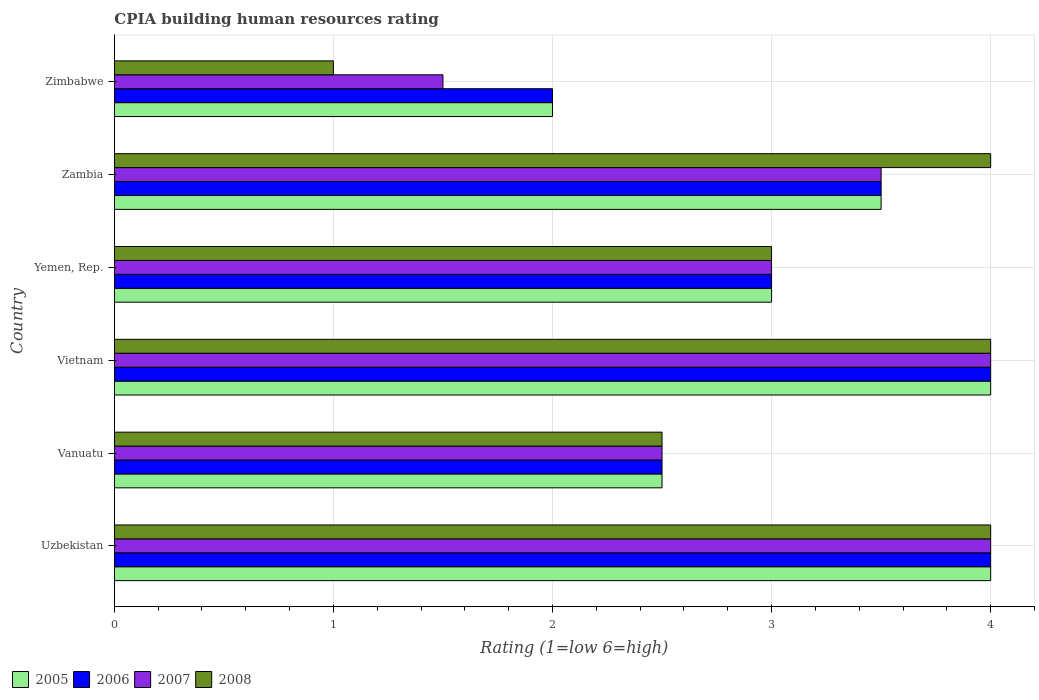How many groups of bars are there?
Offer a very short reply. 6. Are the number of bars per tick equal to the number of legend labels?
Offer a very short reply. Yes. Are the number of bars on each tick of the Y-axis equal?
Ensure brevity in your answer.  Yes. How many bars are there on the 1st tick from the bottom?
Make the answer very short. 4. What is the label of the 4th group of bars from the top?
Provide a short and direct response. Vietnam. What is the CPIA rating in 2006 in Uzbekistan?
Keep it short and to the point. 4. Across all countries, what is the maximum CPIA rating in 2005?
Provide a succinct answer. 4. In which country was the CPIA rating in 2008 maximum?
Ensure brevity in your answer.  Uzbekistan. In which country was the CPIA rating in 2008 minimum?
Provide a short and direct response. Zimbabwe. What is the total CPIA rating in 2005 in the graph?
Keep it short and to the point. 19. What is the difference between the CPIA rating in 2007 in Zambia and the CPIA rating in 2005 in Vanuatu?
Offer a terse response. 1. What is the average CPIA rating in 2006 per country?
Offer a terse response. 3.17. In how many countries, is the CPIA rating in 2007 greater than 1.8 ?
Offer a very short reply. 5. What is the ratio of the CPIA rating in 2008 in Vanuatu to that in Zimbabwe?
Keep it short and to the point. 2.5. What is the difference between the highest and the lowest CPIA rating in 2008?
Offer a very short reply. 3. What does the 1st bar from the top in Vietnam represents?
Provide a short and direct response. 2008. How many countries are there in the graph?
Offer a terse response. 6. Does the graph contain grids?
Provide a succinct answer. Yes. Where does the legend appear in the graph?
Give a very brief answer. Bottom left. What is the title of the graph?
Your answer should be compact. CPIA building human resources rating. Does "1968" appear as one of the legend labels in the graph?
Your answer should be compact. No. What is the Rating (1=low 6=high) of 2005 in Uzbekistan?
Provide a succinct answer. 4. What is the Rating (1=low 6=high) of 2007 in Uzbekistan?
Provide a short and direct response. 4. What is the Rating (1=low 6=high) of 2008 in Vanuatu?
Offer a very short reply. 2.5. What is the Rating (1=low 6=high) in 2006 in Vietnam?
Provide a succinct answer. 4. What is the Rating (1=low 6=high) in 2007 in Vietnam?
Provide a succinct answer. 4. What is the Rating (1=low 6=high) of 2005 in Yemen, Rep.?
Ensure brevity in your answer.  3. What is the Rating (1=low 6=high) in 2006 in Zambia?
Keep it short and to the point. 3.5. What is the Rating (1=low 6=high) in 2008 in Zambia?
Give a very brief answer. 4. Across all countries, what is the maximum Rating (1=low 6=high) in 2005?
Offer a very short reply. 4. Across all countries, what is the minimum Rating (1=low 6=high) in 2006?
Your response must be concise. 2. Across all countries, what is the minimum Rating (1=low 6=high) in 2008?
Provide a succinct answer. 1. What is the total Rating (1=low 6=high) of 2005 in the graph?
Your response must be concise. 19. What is the total Rating (1=low 6=high) of 2008 in the graph?
Offer a very short reply. 18.5. What is the difference between the Rating (1=low 6=high) of 2008 in Uzbekistan and that in Vanuatu?
Provide a succinct answer. 1.5. What is the difference between the Rating (1=low 6=high) in 2005 in Uzbekistan and that in Vietnam?
Offer a very short reply. 0. What is the difference between the Rating (1=low 6=high) of 2006 in Uzbekistan and that in Vietnam?
Provide a succinct answer. 0. What is the difference between the Rating (1=low 6=high) of 2008 in Uzbekistan and that in Vietnam?
Provide a short and direct response. 0. What is the difference between the Rating (1=low 6=high) of 2005 in Uzbekistan and that in Yemen, Rep.?
Offer a terse response. 1. What is the difference between the Rating (1=low 6=high) in 2008 in Uzbekistan and that in Yemen, Rep.?
Give a very brief answer. 1. What is the difference between the Rating (1=low 6=high) of 2005 in Uzbekistan and that in Zambia?
Ensure brevity in your answer.  0.5. What is the difference between the Rating (1=low 6=high) in 2006 in Uzbekistan and that in Zambia?
Ensure brevity in your answer.  0.5. What is the difference between the Rating (1=low 6=high) in 2008 in Uzbekistan and that in Zambia?
Offer a terse response. 0. What is the difference between the Rating (1=low 6=high) of 2005 in Uzbekistan and that in Zimbabwe?
Ensure brevity in your answer.  2. What is the difference between the Rating (1=low 6=high) of 2007 in Uzbekistan and that in Zimbabwe?
Make the answer very short. 2.5. What is the difference between the Rating (1=low 6=high) of 2005 in Vanuatu and that in Vietnam?
Make the answer very short. -1.5. What is the difference between the Rating (1=low 6=high) in 2006 in Vanuatu and that in Vietnam?
Make the answer very short. -1.5. What is the difference between the Rating (1=low 6=high) of 2007 in Vanuatu and that in Yemen, Rep.?
Give a very brief answer. -0.5. What is the difference between the Rating (1=low 6=high) in 2008 in Vanuatu and that in Yemen, Rep.?
Provide a short and direct response. -0.5. What is the difference between the Rating (1=low 6=high) in 2006 in Vanuatu and that in Zambia?
Offer a very short reply. -1. What is the difference between the Rating (1=low 6=high) in 2007 in Vanuatu and that in Zambia?
Your response must be concise. -1. What is the difference between the Rating (1=low 6=high) in 2008 in Vanuatu and that in Zambia?
Offer a terse response. -1.5. What is the difference between the Rating (1=low 6=high) in 2005 in Vanuatu and that in Zimbabwe?
Your answer should be compact. 0.5. What is the difference between the Rating (1=low 6=high) of 2007 in Vanuatu and that in Zimbabwe?
Offer a very short reply. 1. What is the difference between the Rating (1=low 6=high) in 2008 in Vanuatu and that in Zimbabwe?
Offer a terse response. 1.5. What is the difference between the Rating (1=low 6=high) in 2006 in Vietnam and that in Yemen, Rep.?
Provide a succinct answer. 1. What is the difference between the Rating (1=low 6=high) of 2007 in Vietnam and that in Yemen, Rep.?
Offer a terse response. 1. What is the difference between the Rating (1=low 6=high) in 2005 in Vietnam and that in Zambia?
Offer a very short reply. 0.5. What is the difference between the Rating (1=low 6=high) in 2006 in Vietnam and that in Zambia?
Your answer should be very brief. 0.5. What is the difference between the Rating (1=low 6=high) in 2007 in Vietnam and that in Zambia?
Offer a terse response. 0.5. What is the difference between the Rating (1=low 6=high) of 2008 in Vietnam and that in Zambia?
Offer a terse response. 0. What is the difference between the Rating (1=low 6=high) of 2005 in Vietnam and that in Zimbabwe?
Provide a succinct answer. 2. What is the difference between the Rating (1=low 6=high) in 2006 in Vietnam and that in Zimbabwe?
Provide a short and direct response. 2. What is the difference between the Rating (1=low 6=high) in 2007 in Vietnam and that in Zimbabwe?
Keep it short and to the point. 2.5. What is the difference between the Rating (1=low 6=high) of 2008 in Vietnam and that in Zimbabwe?
Offer a very short reply. 3. What is the difference between the Rating (1=low 6=high) of 2005 in Yemen, Rep. and that in Zambia?
Your answer should be compact. -0.5. What is the difference between the Rating (1=low 6=high) in 2008 in Yemen, Rep. and that in Zambia?
Ensure brevity in your answer.  -1. What is the difference between the Rating (1=low 6=high) in 2005 in Yemen, Rep. and that in Zimbabwe?
Provide a succinct answer. 1. What is the difference between the Rating (1=low 6=high) in 2007 in Yemen, Rep. and that in Zimbabwe?
Keep it short and to the point. 1.5. What is the difference between the Rating (1=low 6=high) in 2005 in Zambia and that in Zimbabwe?
Offer a very short reply. 1.5. What is the difference between the Rating (1=low 6=high) in 2005 in Uzbekistan and the Rating (1=low 6=high) in 2006 in Vanuatu?
Your answer should be compact. 1.5. What is the difference between the Rating (1=low 6=high) in 2006 in Uzbekistan and the Rating (1=low 6=high) in 2007 in Vanuatu?
Your answer should be compact. 1.5. What is the difference between the Rating (1=low 6=high) of 2005 in Uzbekistan and the Rating (1=low 6=high) of 2006 in Vietnam?
Give a very brief answer. 0. What is the difference between the Rating (1=low 6=high) of 2007 in Uzbekistan and the Rating (1=low 6=high) of 2008 in Vietnam?
Your answer should be compact. 0. What is the difference between the Rating (1=low 6=high) of 2005 in Uzbekistan and the Rating (1=low 6=high) of 2008 in Yemen, Rep.?
Keep it short and to the point. 1. What is the difference between the Rating (1=low 6=high) in 2006 in Uzbekistan and the Rating (1=low 6=high) in 2007 in Yemen, Rep.?
Offer a very short reply. 1. What is the difference between the Rating (1=low 6=high) of 2006 in Uzbekistan and the Rating (1=low 6=high) of 2008 in Yemen, Rep.?
Provide a short and direct response. 1. What is the difference between the Rating (1=low 6=high) of 2007 in Uzbekistan and the Rating (1=low 6=high) of 2008 in Yemen, Rep.?
Your response must be concise. 1. What is the difference between the Rating (1=low 6=high) in 2005 in Uzbekistan and the Rating (1=low 6=high) in 2007 in Zambia?
Provide a succinct answer. 0.5. What is the difference between the Rating (1=low 6=high) in 2006 in Uzbekistan and the Rating (1=low 6=high) in 2007 in Zambia?
Your answer should be compact. 0.5. What is the difference between the Rating (1=low 6=high) of 2007 in Uzbekistan and the Rating (1=low 6=high) of 2008 in Zambia?
Provide a succinct answer. 0. What is the difference between the Rating (1=low 6=high) in 2005 in Uzbekistan and the Rating (1=low 6=high) in 2008 in Zimbabwe?
Your answer should be very brief. 3. What is the difference between the Rating (1=low 6=high) of 2006 in Uzbekistan and the Rating (1=low 6=high) of 2007 in Zimbabwe?
Your answer should be compact. 2.5. What is the difference between the Rating (1=low 6=high) of 2007 in Uzbekistan and the Rating (1=low 6=high) of 2008 in Zimbabwe?
Ensure brevity in your answer.  3. What is the difference between the Rating (1=low 6=high) in 2005 in Vanuatu and the Rating (1=low 6=high) in 2006 in Vietnam?
Offer a terse response. -1.5. What is the difference between the Rating (1=low 6=high) of 2005 in Vanuatu and the Rating (1=low 6=high) of 2007 in Vietnam?
Give a very brief answer. -1.5. What is the difference between the Rating (1=low 6=high) of 2005 in Vanuatu and the Rating (1=low 6=high) of 2007 in Yemen, Rep.?
Your answer should be compact. -0.5. What is the difference between the Rating (1=low 6=high) of 2007 in Vanuatu and the Rating (1=low 6=high) of 2008 in Yemen, Rep.?
Your answer should be very brief. -0.5. What is the difference between the Rating (1=low 6=high) in 2005 in Vanuatu and the Rating (1=low 6=high) in 2006 in Zambia?
Your answer should be compact. -1. What is the difference between the Rating (1=low 6=high) in 2005 in Vanuatu and the Rating (1=low 6=high) in 2007 in Zambia?
Give a very brief answer. -1. What is the difference between the Rating (1=low 6=high) in 2006 in Vanuatu and the Rating (1=low 6=high) in 2007 in Zambia?
Keep it short and to the point. -1. What is the difference between the Rating (1=low 6=high) of 2006 in Vanuatu and the Rating (1=low 6=high) of 2008 in Zambia?
Your answer should be compact. -1.5. What is the difference between the Rating (1=low 6=high) of 2007 in Vanuatu and the Rating (1=low 6=high) of 2008 in Zambia?
Ensure brevity in your answer.  -1.5. What is the difference between the Rating (1=low 6=high) of 2005 in Vanuatu and the Rating (1=low 6=high) of 2006 in Zimbabwe?
Offer a terse response. 0.5. What is the difference between the Rating (1=low 6=high) of 2005 in Vanuatu and the Rating (1=low 6=high) of 2007 in Zimbabwe?
Your response must be concise. 1. What is the difference between the Rating (1=low 6=high) of 2005 in Vanuatu and the Rating (1=low 6=high) of 2008 in Zimbabwe?
Ensure brevity in your answer.  1.5. What is the difference between the Rating (1=low 6=high) of 2007 in Vanuatu and the Rating (1=low 6=high) of 2008 in Zimbabwe?
Provide a short and direct response. 1.5. What is the difference between the Rating (1=low 6=high) in 2005 in Vietnam and the Rating (1=low 6=high) in 2008 in Yemen, Rep.?
Make the answer very short. 1. What is the difference between the Rating (1=low 6=high) in 2006 in Vietnam and the Rating (1=low 6=high) in 2008 in Yemen, Rep.?
Make the answer very short. 1. What is the difference between the Rating (1=low 6=high) of 2005 in Vietnam and the Rating (1=low 6=high) of 2006 in Zambia?
Offer a very short reply. 0.5. What is the difference between the Rating (1=low 6=high) of 2005 in Vietnam and the Rating (1=low 6=high) of 2007 in Zambia?
Ensure brevity in your answer.  0.5. What is the difference between the Rating (1=low 6=high) of 2005 in Vietnam and the Rating (1=low 6=high) of 2006 in Zimbabwe?
Provide a succinct answer. 2. What is the difference between the Rating (1=low 6=high) in 2006 in Vietnam and the Rating (1=low 6=high) in 2008 in Zimbabwe?
Keep it short and to the point. 3. What is the difference between the Rating (1=low 6=high) of 2007 in Vietnam and the Rating (1=low 6=high) of 2008 in Zimbabwe?
Make the answer very short. 3. What is the difference between the Rating (1=low 6=high) of 2005 in Yemen, Rep. and the Rating (1=low 6=high) of 2007 in Zambia?
Offer a terse response. -0.5. What is the difference between the Rating (1=low 6=high) in 2006 in Yemen, Rep. and the Rating (1=low 6=high) in 2008 in Zambia?
Offer a very short reply. -1. What is the difference between the Rating (1=low 6=high) in 2005 in Yemen, Rep. and the Rating (1=low 6=high) in 2006 in Zimbabwe?
Offer a very short reply. 1. What is the difference between the Rating (1=low 6=high) of 2005 in Yemen, Rep. and the Rating (1=low 6=high) of 2007 in Zimbabwe?
Make the answer very short. 1.5. What is the difference between the Rating (1=low 6=high) of 2006 in Yemen, Rep. and the Rating (1=low 6=high) of 2007 in Zimbabwe?
Ensure brevity in your answer.  1.5. What is the difference between the Rating (1=low 6=high) in 2005 in Zambia and the Rating (1=low 6=high) in 2007 in Zimbabwe?
Offer a terse response. 2. What is the difference between the Rating (1=low 6=high) in 2007 in Zambia and the Rating (1=low 6=high) in 2008 in Zimbabwe?
Give a very brief answer. 2.5. What is the average Rating (1=low 6=high) in 2005 per country?
Your response must be concise. 3.17. What is the average Rating (1=low 6=high) in 2006 per country?
Your answer should be very brief. 3.17. What is the average Rating (1=low 6=high) in 2007 per country?
Give a very brief answer. 3.08. What is the average Rating (1=low 6=high) in 2008 per country?
Your answer should be compact. 3.08. What is the difference between the Rating (1=low 6=high) in 2005 and Rating (1=low 6=high) in 2006 in Uzbekistan?
Your response must be concise. 0. What is the difference between the Rating (1=low 6=high) of 2005 and Rating (1=low 6=high) of 2007 in Uzbekistan?
Your response must be concise. 0. What is the difference between the Rating (1=low 6=high) of 2005 and Rating (1=low 6=high) of 2008 in Uzbekistan?
Offer a terse response. 0. What is the difference between the Rating (1=low 6=high) in 2006 and Rating (1=low 6=high) in 2007 in Uzbekistan?
Provide a succinct answer. 0. What is the difference between the Rating (1=low 6=high) in 2005 and Rating (1=low 6=high) in 2008 in Vanuatu?
Provide a short and direct response. 0. What is the difference between the Rating (1=low 6=high) in 2006 and Rating (1=low 6=high) in 2008 in Vanuatu?
Make the answer very short. 0. What is the difference between the Rating (1=low 6=high) of 2005 and Rating (1=low 6=high) of 2006 in Vietnam?
Your answer should be very brief. 0. What is the difference between the Rating (1=low 6=high) in 2005 and Rating (1=low 6=high) in 2007 in Vietnam?
Ensure brevity in your answer.  0. What is the difference between the Rating (1=low 6=high) in 2005 and Rating (1=low 6=high) in 2008 in Vietnam?
Provide a succinct answer. 0. What is the difference between the Rating (1=low 6=high) of 2006 and Rating (1=low 6=high) of 2007 in Vietnam?
Offer a terse response. 0. What is the difference between the Rating (1=low 6=high) of 2006 and Rating (1=low 6=high) of 2008 in Vietnam?
Your answer should be very brief. 0. What is the difference between the Rating (1=low 6=high) in 2005 and Rating (1=low 6=high) in 2006 in Yemen, Rep.?
Provide a succinct answer. 0. What is the difference between the Rating (1=low 6=high) of 2006 and Rating (1=low 6=high) of 2008 in Yemen, Rep.?
Your answer should be compact. 0. What is the difference between the Rating (1=low 6=high) in 2005 and Rating (1=low 6=high) in 2006 in Zambia?
Provide a short and direct response. 0. What is the difference between the Rating (1=low 6=high) in 2005 and Rating (1=low 6=high) in 2007 in Zambia?
Your response must be concise. 0. What is the difference between the Rating (1=low 6=high) in 2005 and Rating (1=low 6=high) in 2008 in Zambia?
Provide a succinct answer. -0.5. What is the difference between the Rating (1=low 6=high) of 2006 and Rating (1=low 6=high) of 2008 in Zambia?
Make the answer very short. -0.5. What is the difference between the Rating (1=low 6=high) in 2005 and Rating (1=low 6=high) in 2006 in Zimbabwe?
Ensure brevity in your answer.  0. What is the difference between the Rating (1=low 6=high) in 2005 and Rating (1=low 6=high) in 2008 in Zimbabwe?
Ensure brevity in your answer.  1. What is the difference between the Rating (1=low 6=high) in 2006 and Rating (1=low 6=high) in 2007 in Zimbabwe?
Give a very brief answer. 0.5. What is the ratio of the Rating (1=low 6=high) of 2005 in Uzbekistan to that in Vanuatu?
Offer a very short reply. 1.6. What is the ratio of the Rating (1=low 6=high) in 2006 in Uzbekistan to that in Vanuatu?
Offer a terse response. 1.6. What is the ratio of the Rating (1=low 6=high) of 2006 in Uzbekistan to that in Vietnam?
Your response must be concise. 1. What is the ratio of the Rating (1=low 6=high) of 2008 in Uzbekistan to that in Zambia?
Provide a succinct answer. 1. What is the ratio of the Rating (1=low 6=high) in 2005 in Uzbekistan to that in Zimbabwe?
Keep it short and to the point. 2. What is the ratio of the Rating (1=low 6=high) in 2006 in Uzbekistan to that in Zimbabwe?
Offer a very short reply. 2. What is the ratio of the Rating (1=low 6=high) of 2007 in Uzbekistan to that in Zimbabwe?
Ensure brevity in your answer.  2.67. What is the ratio of the Rating (1=low 6=high) of 2007 in Vanuatu to that in Vietnam?
Provide a succinct answer. 0.62. What is the ratio of the Rating (1=low 6=high) of 2008 in Vanuatu to that in Yemen, Rep.?
Give a very brief answer. 0.83. What is the ratio of the Rating (1=low 6=high) of 2005 in Vanuatu to that in Zambia?
Your answer should be very brief. 0.71. What is the ratio of the Rating (1=low 6=high) of 2006 in Vanuatu to that in Zambia?
Keep it short and to the point. 0.71. What is the ratio of the Rating (1=low 6=high) in 2007 in Vanuatu to that in Zambia?
Give a very brief answer. 0.71. What is the ratio of the Rating (1=low 6=high) of 2008 in Vanuatu to that in Zambia?
Provide a short and direct response. 0.62. What is the ratio of the Rating (1=low 6=high) in 2006 in Vanuatu to that in Zimbabwe?
Offer a terse response. 1.25. What is the ratio of the Rating (1=low 6=high) in 2007 in Vietnam to that in Zambia?
Ensure brevity in your answer.  1.14. What is the ratio of the Rating (1=low 6=high) of 2008 in Vietnam to that in Zambia?
Provide a short and direct response. 1. What is the ratio of the Rating (1=low 6=high) in 2005 in Vietnam to that in Zimbabwe?
Make the answer very short. 2. What is the ratio of the Rating (1=low 6=high) in 2006 in Vietnam to that in Zimbabwe?
Your answer should be very brief. 2. What is the ratio of the Rating (1=low 6=high) of 2007 in Vietnam to that in Zimbabwe?
Provide a short and direct response. 2.67. What is the ratio of the Rating (1=low 6=high) of 2008 in Vietnam to that in Zimbabwe?
Provide a short and direct response. 4. What is the ratio of the Rating (1=low 6=high) of 2005 in Yemen, Rep. to that in Zambia?
Provide a succinct answer. 0.86. What is the ratio of the Rating (1=low 6=high) in 2006 in Yemen, Rep. to that in Zambia?
Make the answer very short. 0.86. What is the ratio of the Rating (1=low 6=high) of 2007 in Yemen, Rep. to that in Zambia?
Offer a very short reply. 0.86. What is the ratio of the Rating (1=low 6=high) of 2005 in Yemen, Rep. to that in Zimbabwe?
Your response must be concise. 1.5. What is the ratio of the Rating (1=low 6=high) of 2006 in Yemen, Rep. to that in Zimbabwe?
Ensure brevity in your answer.  1.5. What is the ratio of the Rating (1=low 6=high) of 2007 in Yemen, Rep. to that in Zimbabwe?
Your answer should be very brief. 2. What is the ratio of the Rating (1=low 6=high) of 2005 in Zambia to that in Zimbabwe?
Ensure brevity in your answer.  1.75. What is the ratio of the Rating (1=low 6=high) of 2006 in Zambia to that in Zimbabwe?
Provide a short and direct response. 1.75. What is the ratio of the Rating (1=low 6=high) of 2007 in Zambia to that in Zimbabwe?
Your response must be concise. 2.33. What is the ratio of the Rating (1=low 6=high) in 2008 in Zambia to that in Zimbabwe?
Give a very brief answer. 4. What is the difference between the highest and the second highest Rating (1=low 6=high) of 2006?
Provide a succinct answer. 0. What is the difference between the highest and the second highest Rating (1=low 6=high) of 2007?
Make the answer very short. 0. What is the difference between the highest and the second highest Rating (1=low 6=high) in 2008?
Your answer should be very brief. 0. What is the difference between the highest and the lowest Rating (1=low 6=high) in 2005?
Provide a short and direct response. 2. What is the difference between the highest and the lowest Rating (1=low 6=high) of 2007?
Keep it short and to the point. 2.5. What is the difference between the highest and the lowest Rating (1=low 6=high) in 2008?
Offer a terse response. 3. 